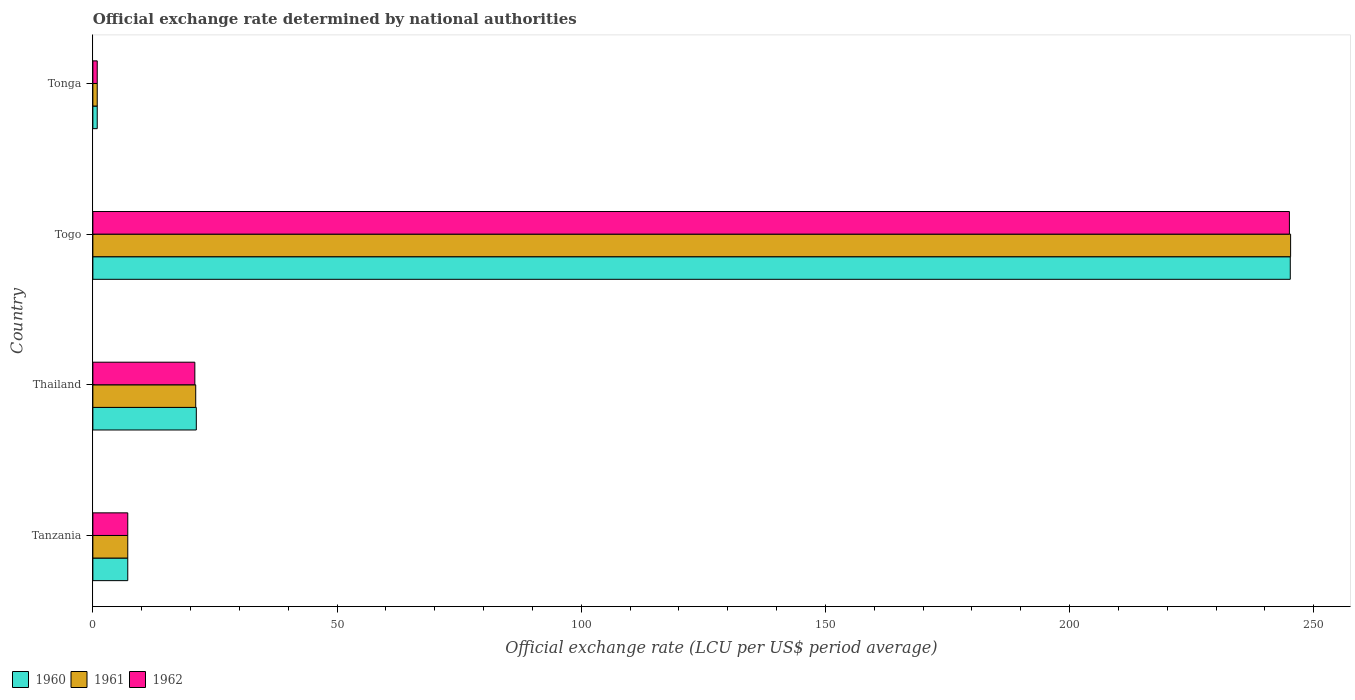Are the number of bars on each tick of the Y-axis equal?
Offer a very short reply. Yes. How many bars are there on the 3rd tick from the top?
Your response must be concise. 3. How many bars are there on the 1st tick from the bottom?
Offer a terse response. 3. What is the label of the 4th group of bars from the top?
Make the answer very short. Tanzania. In how many cases, is the number of bars for a given country not equal to the number of legend labels?
Ensure brevity in your answer.  0. What is the official exchange rate in 1962 in Togo?
Your answer should be very brief. 245.01. Across all countries, what is the maximum official exchange rate in 1960?
Offer a terse response. 245.2. Across all countries, what is the minimum official exchange rate in 1961?
Your answer should be compact. 0.89. In which country was the official exchange rate in 1962 maximum?
Ensure brevity in your answer.  Togo. In which country was the official exchange rate in 1961 minimum?
Offer a terse response. Tonga. What is the total official exchange rate in 1960 in the graph?
Keep it short and to the point. 274.41. What is the difference between the official exchange rate in 1962 in Togo and that in Tonga?
Ensure brevity in your answer.  244.12. What is the difference between the official exchange rate in 1962 in Tonga and the official exchange rate in 1961 in Togo?
Provide a succinct answer. -244.37. What is the average official exchange rate in 1962 per country?
Offer a terse response. 68.48. What is the difference between the official exchange rate in 1962 and official exchange rate in 1960 in Tonga?
Offer a very short reply. 0. In how many countries, is the official exchange rate in 1961 greater than 220 LCU?
Give a very brief answer. 1. What is the ratio of the official exchange rate in 1961 in Thailand to that in Togo?
Provide a succinct answer. 0.09. Is the difference between the official exchange rate in 1962 in Togo and Tonga greater than the difference between the official exchange rate in 1960 in Togo and Tonga?
Keep it short and to the point. No. What is the difference between the highest and the second highest official exchange rate in 1962?
Make the answer very short. 224.13. What is the difference between the highest and the lowest official exchange rate in 1961?
Provide a short and direct response. 244.37. In how many countries, is the official exchange rate in 1961 greater than the average official exchange rate in 1961 taken over all countries?
Provide a short and direct response. 1. Is the sum of the official exchange rate in 1960 in Thailand and Togo greater than the maximum official exchange rate in 1961 across all countries?
Make the answer very short. Yes. What does the 3rd bar from the bottom in Togo represents?
Your response must be concise. 1962. Does the graph contain any zero values?
Offer a terse response. No. Does the graph contain grids?
Your answer should be compact. No. Where does the legend appear in the graph?
Give a very brief answer. Bottom left. How many legend labels are there?
Make the answer very short. 3. What is the title of the graph?
Offer a terse response. Official exchange rate determined by national authorities. What is the label or title of the X-axis?
Keep it short and to the point. Official exchange rate (LCU per US$ period average). What is the label or title of the Y-axis?
Offer a very short reply. Country. What is the Official exchange rate (LCU per US$ period average) in 1960 in Tanzania?
Your answer should be compact. 7.14. What is the Official exchange rate (LCU per US$ period average) of 1961 in Tanzania?
Keep it short and to the point. 7.14. What is the Official exchange rate (LCU per US$ period average) of 1962 in Tanzania?
Your answer should be very brief. 7.14. What is the Official exchange rate (LCU per US$ period average) in 1960 in Thailand?
Offer a very short reply. 21.18. What is the Official exchange rate (LCU per US$ period average) of 1961 in Thailand?
Offer a terse response. 21.06. What is the Official exchange rate (LCU per US$ period average) of 1962 in Thailand?
Your answer should be very brief. 20.88. What is the Official exchange rate (LCU per US$ period average) in 1960 in Togo?
Give a very brief answer. 245.2. What is the Official exchange rate (LCU per US$ period average) of 1961 in Togo?
Ensure brevity in your answer.  245.26. What is the Official exchange rate (LCU per US$ period average) of 1962 in Togo?
Your response must be concise. 245.01. What is the Official exchange rate (LCU per US$ period average) of 1960 in Tonga?
Provide a succinct answer. 0.89. What is the Official exchange rate (LCU per US$ period average) in 1961 in Tonga?
Your answer should be very brief. 0.89. What is the Official exchange rate (LCU per US$ period average) in 1962 in Tonga?
Offer a very short reply. 0.89. Across all countries, what is the maximum Official exchange rate (LCU per US$ period average) in 1960?
Give a very brief answer. 245.2. Across all countries, what is the maximum Official exchange rate (LCU per US$ period average) in 1961?
Ensure brevity in your answer.  245.26. Across all countries, what is the maximum Official exchange rate (LCU per US$ period average) in 1962?
Offer a very short reply. 245.01. Across all countries, what is the minimum Official exchange rate (LCU per US$ period average) in 1960?
Make the answer very short. 0.89. Across all countries, what is the minimum Official exchange rate (LCU per US$ period average) in 1961?
Your answer should be compact. 0.89. Across all countries, what is the minimum Official exchange rate (LCU per US$ period average) of 1962?
Provide a short and direct response. 0.89. What is the total Official exchange rate (LCU per US$ period average) of 1960 in the graph?
Your answer should be very brief. 274.41. What is the total Official exchange rate (LCU per US$ period average) in 1961 in the graph?
Your answer should be very brief. 274.35. What is the total Official exchange rate (LCU per US$ period average) of 1962 in the graph?
Ensure brevity in your answer.  273.93. What is the difference between the Official exchange rate (LCU per US$ period average) in 1960 in Tanzania and that in Thailand?
Offer a very short reply. -14.04. What is the difference between the Official exchange rate (LCU per US$ period average) in 1961 in Tanzania and that in Thailand?
Your answer should be compact. -13.92. What is the difference between the Official exchange rate (LCU per US$ period average) of 1962 in Tanzania and that in Thailand?
Ensure brevity in your answer.  -13.74. What is the difference between the Official exchange rate (LCU per US$ period average) of 1960 in Tanzania and that in Togo?
Keep it short and to the point. -238.05. What is the difference between the Official exchange rate (LCU per US$ period average) of 1961 in Tanzania and that in Togo?
Give a very brief answer. -238.12. What is the difference between the Official exchange rate (LCU per US$ period average) in 1962 in Tanzania and that in Togo?
Your answer should be very brief. -237.87. What is the difference between the Official exchange rate (LCU per US$ period average) of 1960 in Tanzania and that in Tonga?
Offer a very short reply. 6.25. What is the difference between the Official exchange rate (LCU per US$ period average) of 1961 in Tanzania and that in Tonga?
Your answer should be compact. 6.25. What is the difference between the Official exchange rate (LCU per US$ period average) in 1962 in Tanzania and that in Tonga?
Your answer should be compact. 6.25. What is the difference between the Official exchange rate (LCU per US$ period average) of 1960 in Thailand and that in Togo?
Provide a succinct answer. -224.01. What is the difference between the Official exchange rate (LCU per US$ period average) of 1961 in Thailand and that in Togo?
Give a very brief answer. -224.2. What is the difference between the Official exchange rate (LCU per US$ period average) in 1962 in Thailand and that in Togo?
Your answer should be very brief. -224.13. What is the difference between the Official exchange rate (LCU per US$ period average) in 1960 in Thailand and that in Tonga?
Keep it short and to the point. 20.29. What is the difference between the Official exchange rate (LCU per US$ period average) of 1961 in Thailand and that in Tonga?
Make the answer very short. 20.17. What is the difference between the Official exchange rate (LCU per US$ period average) in 1962 in Thailand and that in Tonga?
Offer a terse response. 19.99. What is the difference between the Official exchange rate (LCU per US$ period average) of 1960 in Togo and that in Tonga?
Provide a succinct answer. 244.3. What is the difference between the Official exchange rate (LCU per US$ period average) of 1961 in Togo and that in Tonga?
Offer a terse response. 244.37. What is the difference between the Official exchange rate (LCU per US$ period average) of 1962 in Togo and that in Tonga?
Your response must be concise. 244.12. What is the difference between the Official exchange rate (LCU per US$ period average) in 1960 in Tanzania and the Official exchange rate (LCU per US$ period average) in 1961 in Thailand?
Provide a succinct answer. -13.92. What is the difference between the Official exchange rate (LCU per US$ period average) of 1960 in Tanzania and the Official exchange rate (LCU per US$ period average) of 1962 in Thailand?
Your answer should be very brief. -13.74. What is the difference between the Official exchange rate (LCU per US$ period average) of 1961 in Tanzania and the Official exchange rate (LCU per US$ period average) of 1962 in Thailand?
Give a very brief answer. -13.74. What is the difference between the Official exchange rate (LCU per US$ period average) in 1960 in Tanzania and the Official exchange rate (LCU per US$ period average) in 1961 in Togo?
Keep it short and to the point. -238.12. What is the difference between the Official exchange rate (LCU per US$ period average) in 1960 in Tanzania and the Official exchange rate (LCU per US$ period average) in 1962 in Togo?
Provide a short and direct response. -237.87. What is the difference between the Official exchange rate (LCU per US$ period average) of 1961 in Tanzania and the Official exchange rate (LCU per US$ period average) of 1962 in Togo?
Provide a succinct answer. -237.87. What is the difference between the Official exchange rate (LCU per US$ period average) in 1960 in Tanzania and the Official exchange rate (LCU per US$ period average) in 1961 in Tonga?
Make the answer very short. 6.25. What is the difference between the Official exchange rate (LCU per US$ period average) of 1960 in Tanzania and the Official exchange rate (LCU per US$ period average) of 1962 in Tonga?
Offer a terse response. 6.25. What is the difference between the Official exchange rate (LCU per US$ period average) of 1961 in Tanzania and the Official exchange rate (LCU per US$ period average) of 1962 in Tonga?
Offer a very short reply. 6.25. What is the difference between the Official exchange rate (LCU per US$ period average) in 1960 in Thailand and the Official exchange rate (LCU per US$ period average) in 1961 in Togo?
Ensure brevity in your answer.  -224.08. What is the difference between the Official exchange rate (LCU per US$ period average) of 1960 in Thailand and the Official exchange rate (LCU per US$ period average) of 1962 in Togo?
Give a very brief answer. -223.83. What is the difference between the Official exchange rate (LCU per US$ period average) of 1961 in Thailand and the Official exchange rate (LCU per US$ period average) of 1962 in Togo?
Provide a short and direct response. -223.96. What is the difference between the Official exchange rate (LCU per US$ period average) in 1960 in Thailand and the Official exchange rate (LCU per US$ period average) in 1961 in Tonga?
Ensure brevity in your answer.  20.29. What is the difference between the Official exchange rate (LCU per US$ period average) in 1960 in Thailand and the Official exchange rate (LCU per US$ period average) in 1962 in Tonga?
Keep it short and to the point. 20.29. What is the difference between the Official exchange rate (LCU per US$ period average) in 1961 in Thailand and the Official exchange rate (LCU per US$ period average) in 1962 in Tonga?
Offer a terse response. 20.17. What is the difference between the Official exchange rate (LCU per US$ period average) in 1960 in Togo and the Official exchange rate (LCU per US$ period average) in 1961 in Tonga?
Your answer should be very brief. 244.3. What is the difference between the Official exchange rate (LCU per US$ period average) of 1960 in Togo and the Official exchange rate (LCU per US$ period average) of 1962 in Tonga?
Offer a very short reply. 244.3. What is the difference between the Official exchange rate (LCU per US$ period average) of 1961 in Togo and the Official exchange rate (LCU per US$ period average) of 1962 in Tonga?
Offer a terse response. 244.37. What is the average Official exchange rate (LCU per US$ period average) of 1960 per country?
Your answer should be compact. 68.6. What is the average Official exchange rate (LCU per US$ period average) of 1961 per country?
Provide a short and direct response. 68.59. What is the average Official exchange rate (LCU per US$ period average) of 1962 per country?
Provide a short and direct response. 68.48. What is the difference between the Official exchange rate (LCU per US$ period average) of 1961 and Official exchange rate (LCU per US$ period average) of 1962 in Tanzania?
Your answer should be compact. 0. What is the difference between the Official exchange rate (LCU per US$ period average) in 1960 and Official exchange rate (LCU per US$ period average) in 1961 in Thailand?
Make the answer very short. 0.12. What is the difference between the Official exchange rate (LCU per US$ period average) of 1960 and Official exchange rate (LCU per US$ period average) of 1962 in Thailand?
Offer a terse response. 0.3. What is the difference between the Official exchange rate (LCU per US$ period average) in 1961 and Official exchange rate (LCU per US$ period average) in 1962 in Thailand?
Give a very brief answer. 0.18. What is the difference between the Official exchange rate (LCU per US$ period average) of 1960 and Official exchange rate (LCU per US$ period average) of 1961 in Togo?
Ensure brevity in your answer.  -0.07. What is the difference between the Official exchange rate (LCU per US$ period average) in 1960 and Official exchange rate (LCU per US$ period average) in 1962 in Togo?
Your answer should be compact. 0.18. What is the difference between the Official exchange rate (LCU per US$ period average) in 1961 and Official exchange rate (LCU per US$ period average) in 1962 in Togo?
Your answer should be very brief. 0.25. What is the ratio of the Official exchange rate (LCU per US$ period average) of 1960 in Tanzania to that in Thailand?
Your answer should be very brief. 0.34. What is the ratio of the Official exchange rate (LCU per US$ period average) of 1961 in Tanzania to that in Thailand?
Your answer should be very brief. 0.34. What is the ratio of the Official exchange rate (LCU per US$ period average) in 1962 in Tanzania to that in Thailand?
Your answer should be very brief. 0.34. What is the ratio of the Official exchange rate (LCU per US$ period average) in 1960 in Tanzania to that in Togo?
Your answer should be very brief. 0.03. What is the ratio of the Official exchange rate (LCU per US$ period average) of 1961 in Tanzania to that in Togo?
Your response must be concise. 0.03. What is the ratio of the Official exchange rate (LCU per US$ period average) in 1962 in Tanzania to that in Togo?
Ensure brevity in your answer.  0.03. What is the ratio of the Official exchange rate (LCU per US$ period average) of 1960 in Thailand to that in Togo?
Give a very brief answer. 0.09. What is the ratio of the Official exchange rate (LCU per US$ period average) in 1961 in Thailand to that in Togo?
Give a very brief answer. 0.09. What is the ratio of the Official exchange rate (LCU per US$ period average) of 1962 in Thailand to that in Togo?
Offer a terse response. 0.09. What is the ratio of the Official exchange rate (LCU per US$ period average) in 1960 in Thailand to that in Tonga?
Give a very brief answer. 23.72. What is the ratio of the Official exchange rate (LCU per US$ period average) of 1961 in Thailand to that in Tonga?
Provide a short and direct response. 23.59. What is the ratio of the Official exchange rate (LCU per US$ period average) in 1962 in Thailand to that in Tonga?
Provide a succinct answer. 23.39. What is the ratio of the Official exchange rate (LCU per US$ period average) of 1960 in Togo to that in Tonga?
Ensure brevity in your answer.  274.62. What is the ratio of the Official exchange rate (LCU per US$ period average) in 1961 in Togo to that in Tonga?
Give a very brief answer. 274.69. What is the ratio of the Official exchange rate (LCU per US$ period average) of 1962 in Togo to that in Tonga?
Your answer should be very brief. 274.42. What is the difference between the highest and the second highest Official exchange rate (LCU per US$ period average) of 1960?
Your answer should be very brief. 224.01. What is the difference between the highest and the second highest Official exchange rate (LCU per US$ period average) of 1961?
Give a very brief answer. 224.2. What is the difference between the highest and the second highest Official exchange rate (LCU per US$ period average) in 1962?
Your response must be concise. 224.13. What is the difference between the highest and the lowest Official exchange rate (LCU per US$ period average) in 1960?
Give a very brief answer. 244.3. What is the difference between the highest and the lowest Official exchange rate (LCU per US$ period average) of 1961?
Keep it short and to the point. 244.37. What is the difference between the highest and the lowest Official exchange rate (LCU per US$ period average) of 1962?
Keep it short and to the point. 244.12. 